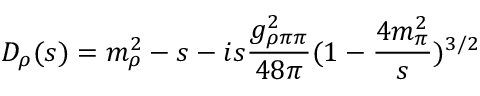Convert formula to latex. <formula><loc_0><loc_0><loc_500><loc_500>D _ { \rho } ( s ) = m _ { \rho } ^ { 2 } - s - i s \frac { g _ { \rho \pi \pi } ^ { 2 } } { 4 8 \pi } ( 1 - \frac { 4 m _ { \pi } ^ { 2 } } { s } ) ^ { 3 / 2 }</formula> 